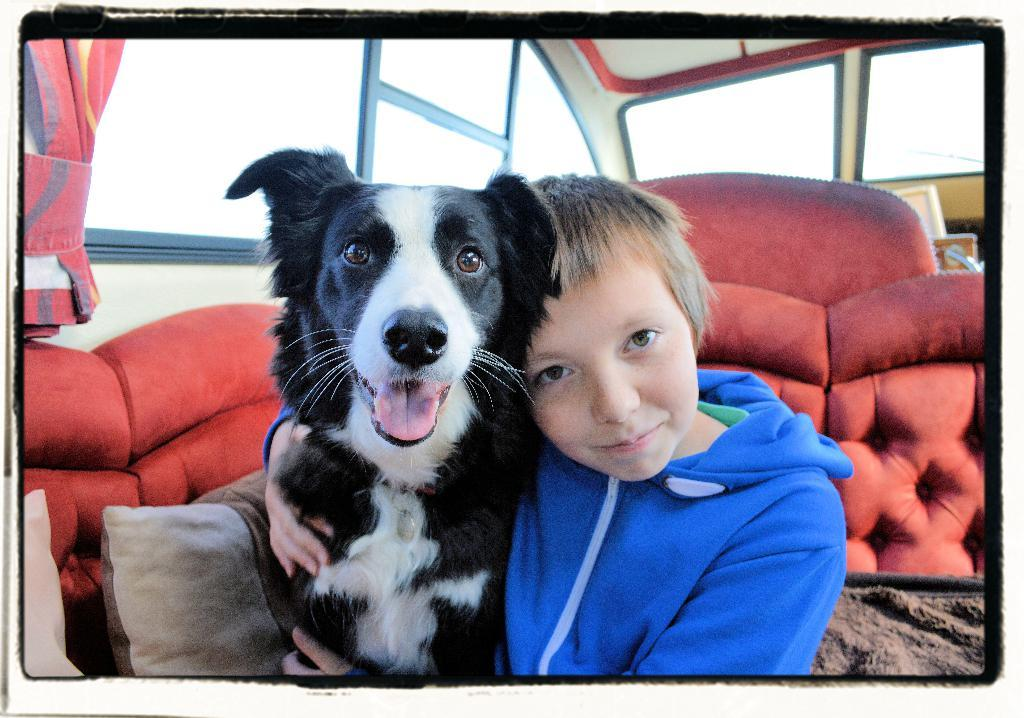Who is the main subject in the image? There is a boy in the image. What is the boy doing in the image? The boy is sitting in the image. What is the boy holding in the image? The boy is holding a dog in the image. What can be seen in the background of the image? There is a red sofa and a glass door in the background of the image. What type of club does the boy use to play with the dog in the image? There is no club present in the image; the boy is holding a dog, not a club. 